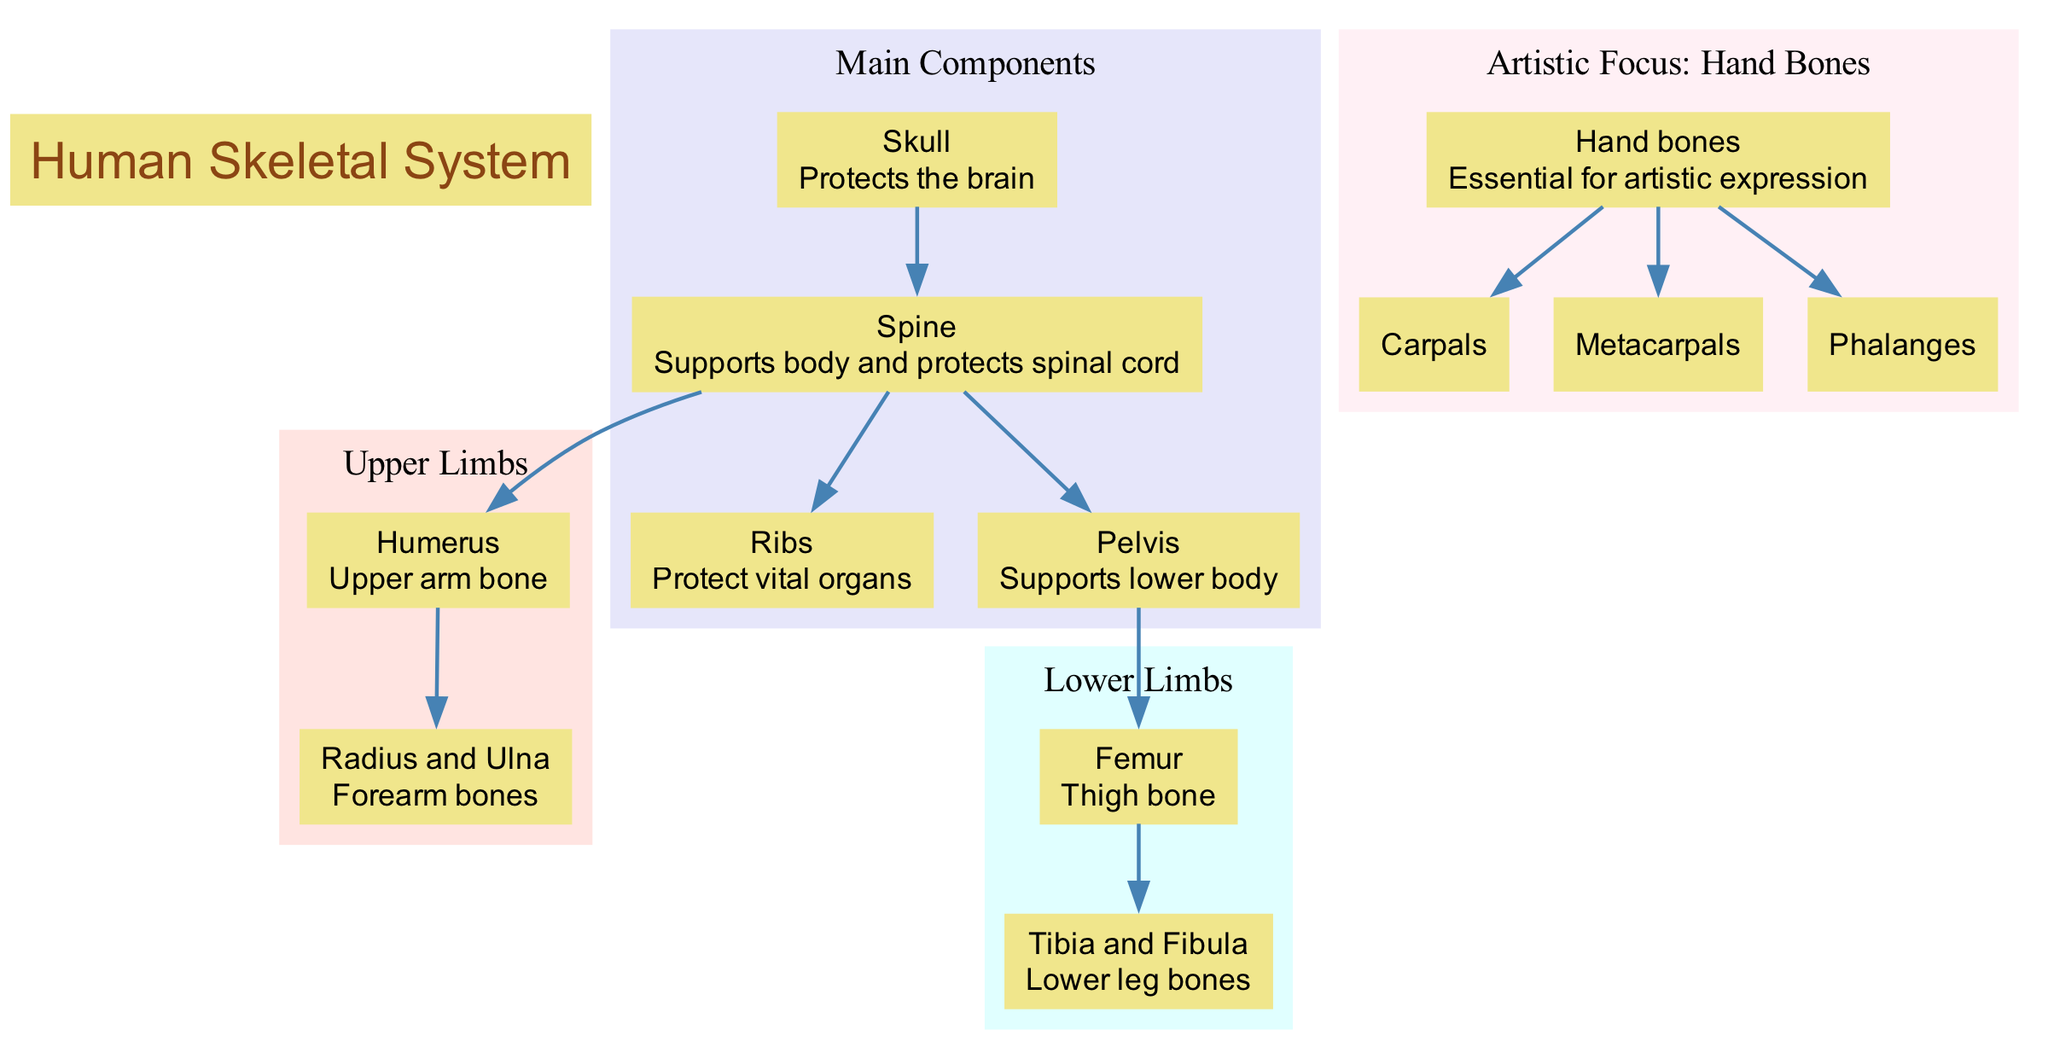What protects the brain? According to the diagram, the "Skull" is labeled as the component that "Protects the brain." Thus, it directly answers the question regarding what provides protection to the brain.
Answer: Skull How many main components are there? The diagram explicitly shows four main components listed under "Main Components": Skull, Spine, Ribs, and Pelvis. By counting these, we find there are four main components.
Answer: 4 What supports the lower body? The "Pelvis" is specified in the diagram to "Supports lower body." This gives a clear indication of which structure serves this function.
Answer: Pelvis Which bone is the upper arm bone? The diagram identifies the "Humerus" as the "Upper arm bone." This provides a direct answer to the query about which bone corresponds to this description.
Answer: Humerus What are the elements of the hand bones? The diagram lists the elements under "Artistic Focus: Hand Bones" as Carpals, Metacarpals, and Phalanges. These are the specific elements referred to in the question.
Answer: Carpals, Metacarpals, Phalanges What bones connect to the spine? The diagram shows the "Ribs," "Humerus," and "Pelvis" as all connected to the "Spine." This requires consideration of multiple parts linked via edges from the spine.
Answer: Ribs, Humerus, Pelvis Which limb contains the femur? The "Femur" is specifically labeled under "Lower Limbs," indicating that this limb contains the femur.
Answer: Lower Limbs How many types of bones are mentioned in the upper limbs? The "Upper Limbs" lists two types of bones: "Humerus" and "Radius and Ulna." This is derived from counting the nodes in the upper limbs section of the diagram.
Answer: 2 What is the function of the spine? The diagram states that the "Spine" "Supports body and protects spinal cord." This clarifies its dual function as described in the diagram.
Answer: Supports body and protects spinal cord 